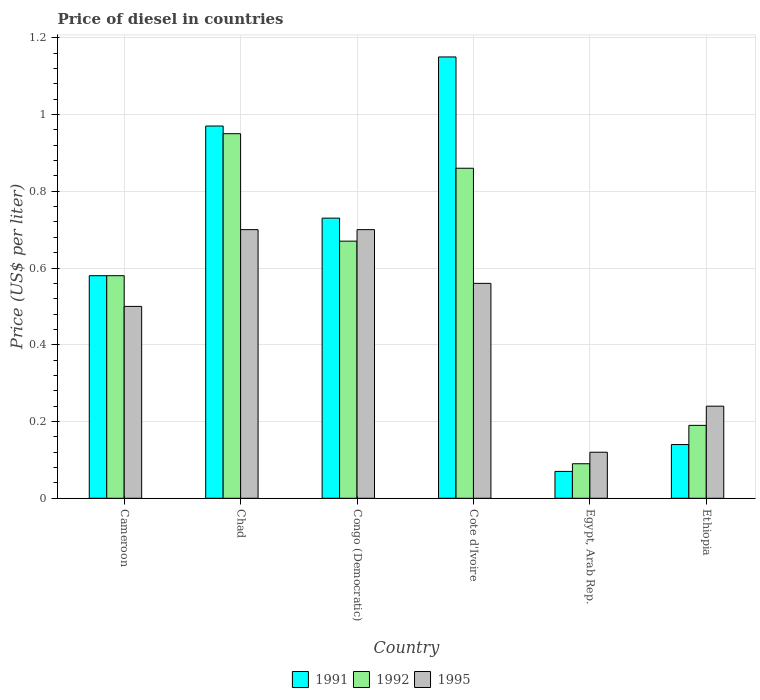How many different coloured bars are there?
Your response must be concise. 3. How many bars are there on the 3rd tick from the right?
Make the answer very short. 3. What is the label of the 3rd group of bars from the left?
Your answer should be compact. Congo (Democratic). In how many cases, is the number of bars for a given country not equal to the number of legend labels?
Make the answer very short. 0. What is the price of diesel in 1992 in Congo (Democratic)?
Ensure brevity in your answer.  0.67. Across all countries, what is the maximum price of diesel in 1992?
Make the answer very short. 0.95. Across all countries, what is the minimum price of diesel in 1992?
Ensure brevity in your answer.  0.09. In which country was the price of diesel in 1992 maximum?
Keep it short and to the point. Chad. In which country was the price of diesel in 1991 minimum?
Give a very brief answer. Egypt, Arab Rep. What is the total price of diesel in 1995 in the graph?
Provide a succinct answer. 2.82. What is the difference between the price of diesel in 1995 in Congo (Democratic) and that in Ethiopia?
Keep it short and to the point. 0.46. What is the difference between the price of diesel in 1992 in Ethiopia and the price of diesel in 1991 in Chad?
Provide a short and direct response. -0.78. What is the average price of diesel in 1991 per country?
Your answer should be very brief. 0.61. What is the difference between the price of diesel of/in 1991 and price of diesel of/in 1992 in Congo (Democratic)?
Your response must be concise. 0.06. What is the ratio of the price of diesel in 1995 in Chad to that in Egypt, Arab Rep.?
Give a very brief answer. 5.83. Is the price of diesel in 1992 in Congo (Democratic) less than that in Ethiopia?
Offer a terse response. No. What is the difference between the highest and the second highest price of diesel in 1995?
Your answer should be very brief. 0.14. What is the difference between the highest and the lowest price of diesel in 1992?
Your answer should be very brief. 0.86. In how many countries, is the price of diesel in 1992 greater than the average price of diesel in 1992 taken over all countries?
Your answer should be compact. 4. What does the 3rd bar from the right in Cameroon represents?
Ensure brevity in your answer.  1991. Is it the case that in every country, the sum of the price of diesel in 1992 and price of diesel in 1991 is greater than the price of diesel in 1995?
Ensure brevity in your answer.  Yes. How many countries are there in the graph?
Offer a very short reply. 6. What is the difference between two consecutive major ticks on the Y-axis?
Offer a terse response. 0.2. Does the graph contain any zero values?
Offer a very short reply. No. Where does the legend appear in the graph?
Your response must be concise. Bottom center. How many legend labels are there?
Offer a very short reply. 3. How are the legend labels stacked?
Keep it short and to the point. Horizontal. What is the title of the graph?
Make the answer very short. Price of diesel in countries. Does "1975" appear as one of the legend labels in the graph?
Offer a very short reply. No. What is the label or title of the Y-axis?
Your response must be concise. Price (US$ per liter). What is the Price (US$ per liter) of 1991 in Cameroon?
Provide a short and direct response. 0.58. What is the Price (US$ per liter) in 1992 in Cameroon?
Ensure brevity in your answer.  0.58. What is the Price (US$ per liter) of 1991 in Chad?
Offer a terse response. 0.97. What is the Price (US$ per liter) in 1995 in Chad?
Offer a very short reply. 0.7. What is the Price (US$ per liter) in 1991 in Congo (Democratic)?
Ensure brevity in your answer.  0.73. What is the Price (US$ per liter) in 1992 in Congo (Democratic)?
Ensure brevity in your answer.  0.67. What is the Price (US$ per liter) of 1991 in Cote d'Ivoire?
Make the answer very short. 1.15. What is the Price (US$ per liter) of 1992 in Cote d'Ivoire?
Your answer should be compact. 0.86. What is the Price (US$ per liter) of 1995 in Cote d'Ivoire?
Your response must be concise. 0.56. What is the Price (US$ per liter) of 1991 in Egypt, Arab Rep.?
Your answer should be compact. 0.07. What is the Price (US$ per liter) in 1992 in Egypt, Arab Rep.?
Offer a very short reply. 0.09. What is the Price (US$ per liter) of 1995 in Egypt, Arab Rep.?
Offer a terse response. 0.12. What is the Price (US$ per liter) of 1991 in Ethiopia?
Give a very brief answer. 0.14. What is the Price (US$ per liter) in 1992 in Ethiopia?
Make the answer very short. 0.19. What is the Price (US$ per liter) of 1995 in Ethiopia?
Your response must be concise. 0.24. Across all countries, what is the maximum Price (US$ per liter) of 1991?
Your answer should be compact. 1.15. Across all countries, what is the maximum Price (US$ per liter) of 1992?
Your response must be concise. 0.95. Across all countries, what is the maximum Price (US$ per liter) of 1995?
Keep it short and to the point. 0.7. Across all countries, what is the minimum Price (US$ per liter) in 1991?
Provide a short and direct response. 0.07. Across all countries, what is the minimum Price (US$ per liter) of 1992?
Ensure brevity in your answer.  0.09. Across all countries, what is the minimum Price (US$ per liter) of 1995?
Your response must be concise. 0.12. What is the total Price (US$ per liter) in 1991 in the graph?
Keep it short and to the point. 3.64. What is the total Price (US$ per liter) of 1992 in the graph?
Provide a short and direct response. 3.34. What is the total Price (US$ per liter) of 1995 in the graph?
Your answer should be very brief. 2.82. What is the difference between the Price (US$ per liter) in 1991 in Cameroon and that in Chad?
Ensure brevity in your answer.  -0.39. What is the difference between the Price (US$ per liter) in 1992 in Cameroon and that in Chad?
Your answer should be very brief. -0.37. What is the difference between the Price (US$ per liter) in 1995 in Cameroon and that in Chad?
Offer a terse response. -0.2. What is the difference between the Price (US$ per liter) in 1992 in Cameroon and that in Congo (Democratic)?
Give a very brief answer. -0.09. What is the difference between the Price (US$ per liter) in 1991 in Cameroon and that in Cote d'Ivoire?
Provide a succinct answer. -0.57. What is the difference between the Price (US$ per liter) in 1992 in Cameroon and that in Cote d'Ivoire?
Provide a short and direct response. -0.28. What is the difference between the Price (US$ per liter) in 1995 in Cameroon and that in Cote d'Ivoire?
Make the answer very short. -0.06. What is the difference between the Price (US$ per liter) in 1991 in Cameroon and that in Egypt, Arab Rep.?
Your answer should be compact. 0.51. What is the difference between the Price (US$ per liter) in 1992 in Cameroon and that in Egypt, Arab Rep.?
Give a very brief answer. 0.49. What is the difference between the Price (US$ per liter) in 1995 in Cameroon and that in Egypt, Arab Rep.?
Your response must be concise. 0.38. What is the difference between the Price (US$ per liter) in 1991 in Cameroon and that in Ethiopia?
Keep it short and to the point. 0.44. What is the difference between the Price (US$ per liter) in 1992 in Cameroon and that in Ethiopia?
Your answer should be compact. 0.39. What is the difference between the Price (US$ per liter) of 1995 in Cameroon and that in Ethiopia?
Make the answer very short. 0.26. What is the difference between the Price (US$ per liter) in 1991 in Chad and that in Congo (Democratic)?
Give a very brief answer. 0.24. What is the difference between the Price (US$ per liter) in 1992 in Chad and that in Congo (Democratic)?
Provide a short and direct response. 0.28. What is the difference between the Price (US$ per liter) of 1995 in Chad and that in Congo (Democratic)?
Make the answer very short. 0. What is the difference between the Price (US$ per liter) in 1991 in Chad and that in Cote d'Ivoire?
Provide a succinct answer. -0.18. What is the difference between the Price (US$ per liter) of 1992 in Chad and that in Cote d'Ivoire?
Your response must be concise. 0.09. What is the difference between the Price (US$ per liter) of 1995 in Chad and that in Cote d'Ivoire?
Keep it short and to the point. 0.14. What is the difference between the Price (US$ per liter) in 1992 in Chad and that in Egypt, Arab Rep.?
Offer a very short reply. 0.86. What is the difference between the Price (US$ per liter) in 1995 in Chad and that in Egypt, Arab Rep.?
Your response must be concise. 0.58. What is the difference between the Price (US$ per liter) of 1991 in Chad and that in Ethiopia?
Your answer should be very brief. 0.83. What is the difference between the Price (US$ per liter) in 1992 in Chad and that in Ethiopia?
Make the answer very short. 0.76. What is the difference between the Price (US$ per liter) in 1995 in Chad and that in Ethiopia?
Give a very brief answer. 0.46. What is the difference between the Price (US$ per liter) of 1991 in Congo (Democratic) and that in Cote d'Ivoire?
Ensure brevity in your answer.  -0.42. What is the difference between the Price (US$ per liter) in 1992 in Congo (Democratic) and that in Cote d'Ivoire?
Your answer should be very brief. -0.19. What is the difference between the Price (US$ per liter) of 1995 in Congo (Democratic) and that in Cote d'Ivoire?
Provide a short and direct response. 0.14. What is the difference between the Price (US$ per liter) of 1991 in Congo (Democratic) and that in Egypt, Arab Rep.?
Provide a short and direct response. 0.66. What is the difference between the Price (US$ per liter) of 1992 in Congo (Democratic) and that in Egypt, Arab Rep.?
Your response must be concise. 0.58. What is the difference between the Price (US$ per liter) of 1995 in Congo (Democratic) and that in Egypt, Arab Rep.?
Give a very brief answer. 0.58. What is the difference between the Price (US$ per liter) in 1991 in Congo (Democratic) and that in Ethiopia?
Ensure brevity in your answer.  0.59. What is the difference between the Price (US$ per liter) in 1992 in Congo (Democratic) and that in Ethiopia?
Ensure brevity in your answer.  0.48. What is the difference between the Price (US$ per liter) of 1995 in Congo (Democratic) and that in Ethiopia?
Provide a short and direct response. 0.46. What is the difference between the Price (US$ per liter) in 1991 in Cote d'Ivoire and that in Egypt, Arab Rep.?
Provide a short and direct response. 1.08. What is the difference between the Price (US$ per liter) in 1992 in Cote d'Ivoire and that in Egypt, Arab Rep.?
Offer a terse response. 0.77. What is the difference between the Price (US$ per liter) of 1995 in Cote d'Ivoire and that in Egypt, Arab Rep.?
Offer a terse response. 0.44. What is the difference between the Price (US$ per liter) in 1991 in Cote d'Ivoire and that in Ethiopia?
Provide a succinct answer. 1.01. What is the difference between the Price (US$ per liter) of 1992 in Cote d'Ivoire and that in Ethiopia?
Make the answer very short. 0.67. What is the difference between the Price (US$ per liter) of 1995 in Cote d'Ivoire and that in Ethiopia?
Provide a succinct answer. 0.32. What is the difference between the Price (US$ per liter) of 1991 in Egypt, Arab Rep. and that in Ethiopia?
Offer a very short reply. -0.07. What is the difference between the Price (US$ per liter) of 1995 in Egypt, Arab Rep. and that in Ethiopia?
Make the answer very short. -0.12. What is the difference between the Price (US$ per liter) in 1991 in Cameroon and the Price (US$ per liter) in 1992 in Chad?
Keep it short and to the point. -0.37. What is the difference between the Price (US$ per liter) in 1991 in Cameroon and the Price (US$ per liter) in 1995 in Chad?
Give a very brief answer. -0.12. What is the difference between the Price (US$ per liter) in 1992 in Cameroon and the Price (US$ per liter) in 1995 in Chad?
Keep it short and to the point. -0.12. What is the difference between the Price (US$ per liter) in 1991 in Cameroon and the Price (US$ per liter) in 1992 in Congo (Democratic)?
Provide a succinct answer. -0.09. What is the difference between the Price (US$ per liter) in 1991 in Cameroon and the Price (US$ per liter) in 1995 in Congo (Democratic)?
Provide a succinct answer. -0.12. What is the difference between the Price (US$ per liter) in 1992 in Cameroon and the Price (US$ per liter) in 1995 in Congo (Democratic)?
Your answer should be compact. -0.12. What is the difference between the Price (US$ per liter) of 1991 in Cameroon and the Price (US$ per liter) of 1992 in Cote d'Ivoire?
Keep it short and to the point. -0.28. What is the difference between the Price (US$ per liter) of 1991 in Cameroon and the Price (US$ per liter) of 1995 in Cote d'Ivoire?
Keep it short and to the point. 0.02. What is the difference between the Price (US$ per liter) in 1992 in Cameroon and the Price (US$ per liter) in 1995 in Cote d'Ivoire?
Offer a very short reply. 0.02. What is the difference between the Price (US$ per liter) of 1991 in Cameroon and the Price (US$ per liter) of 1992 in Egypt, Arab Rep.?
Provide a succinct answer. 0.49. What is the difference between the Price (US$ per liter) in 1991 in Cameroon and the Price (US$ per liter) in 1995 in Egypt, Arab Rep.?
Keep it short and to the point. 0.46. What is the difference between the Price (US$ per liter) in 1992 in Cameroon and the Price (US$ per liter) in 1995 in Egypt, Arab Rep.?
Ensure brevity in your answer.  0.46. What is the difference between the Price (US$ per liter) in 1991 in Cameroon and the Price (US$ per liter) in 1992 in Ethiopia?
Offer a terse response. 0.39. What is the difference between the Price (US$ per liter) in 1991 in Cameroon and the Price (US$ per liter) in 1995 in Ethiopia?
Give a very brief answer. 0.34. What is the difference between the Price (US$ per liter) of 1992 in Cameroon and the Price (US$ per liter) of 1995 in Ethiopia?
Your response must be concise. 0.34. What is the difference between the Price (US$ per liter) in 1991 in Chad and the Price (US$ per liter) in 1992 in Congo (Democratic)?
Offer a very short reply. 0.3. What is the difference between the Price (US$ per liter) of 1991 in Chad and the Price (US$ per liter) of 1995 in Congo (Democratic)?
Provide a succinct answer. 0.27. What is the difference between the Price (US$ per liter) of 1992 in Chad and the Price (US$ per liter) of 1995 in Congo (Democratic)?
Provide a short and direct response. 0.25. What is the difference between the Price (US$ per liter) of 1991 in Chad and the Price (US$ per liter) of 1992 in Cote d'Ivoire?
Your response must be concise. 0.11. What is the difference between the Price (US$ per liter) in 1991 in Chad and the Price (US$ per liter) in 1995 in Cote d'Ivoire?
Ensure brevity in your answer.  0.41. What is the difference between the Price (US$ per liter) of 1992 in Chad and the Price (US$ per liter) of 1995 in Cote d'Ivoire?
Offer a terse response. 0.39. What is the difference between the Price (US$ per liter) in 1991 in Chad and the Price (US$ per liter) in 1995 in Egypt, Arab Rep.?
Keep it short and to the point. 0.85. What is the difference between the Price (US$ per liter) of 1992 in Chad and the Price (US$ per liter) of 1995 in Egypt, Arab Rep.?
Your response must be concise. 0.83. What is the difference between the Price (US$ per liter) of 1991 in Chad and the Price (US$ per liter) of 1992 in Ethiopia?
Offer a very short reply. 0.78. What is the difference between the Price (US$ per liter) in 1991 in Chad and the Price (US$ per liter) in 1995 in Ethiopia?
Offer a terse response. 0.73. What is the difference between the Price (US$ per liter) in 1992 in Chad and the Price (US$ per liter) in 1995 in Ethiopia?
Keep it short and to the point. 0.71. What is the difference between the Price (US$ per liter) in 1991 in Congo (Democratic) and the Price (US$ per liter) in 1992 in Cote d'Ivoire?
Keep it short and to the point. -0.13. What is the difference between the Price (US$ per liter) of 1991 in Congo (Democratic) and the Price (US$ per liter) of 1995 in Cote d'Ivoire?
Give a very brief answer. 0.17. What is the difference between the Price (US$ per liter) of 1992 in Congo (Democratic) and the Price (US$ per liter) of 1995 in Cote d'Ivoire?
Give a very brief answer. 0.11. What is the difference between the Price (US$ per liter) of 1991 in Congo (Democratic) and the Price (US$ per liter) of 1992 in Egypt, Arab Rep.?
Your answer should be compact. 0.64. What is the difference between the Price (US$ per liter) in 1991 in Congo (Democratic) and the Price (US$ per liter) in 1995 in Egypt, Arab Rep.?
Make the answer very short. 0.61. What is the difference between the Price (US$ per liter) in 1992 in Congo (Democratic) and the Price (US$ per liter) in 1995 in Egypt, Arab Rep.?
Make the answer very short. 0.55. What is the difference between the Price (US$ per liter) in 1991 in Congo (Democratic) and the Price (US$ per liter) in 1992 in Ethiopia?
Provide a short and direct response. 0.54. What is the difference between the Price (US$ per liter) of 1991 in Congo (Democratic) and the Price (US$ per liter) of 1995 in Ethiopia?
Keep it short and to the point. 0.49. What is the difference between the Price (US$ per liter) in 1992 in Congo (Democratic) and the Price (US$ per liter) in 1995 in Ethiopia?
Offer a terse response. 0.43. What is the difference between the Price (US$ per liter) in 1991 in Cote d'Ivoire and the Price (US$ per liter) in 1992 in Egypt, Arab Rep.?
Your response must be concise. 1.06. What is the difference between the Price (US$ per liter) in 1992 in Cote d'Ivoire and the Price (US$ per liter) in 1995 in Egypt, Arab Rep.?
Your answer should be compact. 0.74. What is the difference between the Price (US$ per liter) of 1991 in Cote d'Ivoire and the Price (US$ per liter) of 1992 in Ethiopia?
Provide a short and direct response. 0.96. What is the difference between the Price (US$ per liter) in 1991 in Cote d'Ivoire and the Price (US$ per liter) in 1995 in Ethiopia?
Your answer should be very brief. 0.91. What is the difference between the Price (US$ per liter) in 1992 in Cote d'Ivoire and the Price (US$ per liter) in 1995 in Ethiopia?
Offer a very short reply. 0.62. What is the difference between the Price (US$ per liter) in 1991 in Egypt, Arab Rep. and the Price (US$ per liter) in 1992 in Ethiopia?
Provide a short and direct response. -0.12. What is the difference between the Price (US$ per liter) of 1991 in Egypt, Arab Rep. and the Price (US$ per liter) of 1995 in Ethiopia?
Provide a short and direct response. -0.17. What is the average Price (US$ per liter) in 1991 per country?
Make the answer very short. 0.61. What is the average Price (US$ per liter) in 1992 per country?
Keep it short and to the point. 0.56. What is the average Price (US$ per liter) of 1995 per country?
Your answer should be very brief. 0.47. What is the difference between the Price (US$ per liter) in 1991 and Price (US$ per liter) in 1992 in Cameroon?
Provide a succinct answer. 0. What is the difference between the Price (US$ per liter) of 1992 and Price (US$ per liter) of 1995 in Cameroon?
Keep it short and to the point. 0.08. What is the difference between the Price (US$ per liter) of 1991 and Price (US$ per liter) of 1995 in Chad?
Your answer should be very brief. 0.27. What is the difference between the Price (US$ per liter) in 1992 and Price (US$ per liter) in 1995 in Chad?
Provide a short and direct response. 0.25. What is the difference between the Price (US$ per liter) of 1991 and Price (US$ per liter) of 1992 in Congo (Democratic)?
Provide a succinct answer. 0.06. What is the difference between the Price (US$ per liter) in 1992 and Price (US$ per liter) in 1995 in Congo (Democratic)?
Ensure brevity in your answer.  -0.03. What is the difference between the Price (US$ per liter) in 1991 and Price (US$ per liter) in 1992 in Cote d'Ivoire?
Give a very brief answer. 0.29. What is the difference between the Price (US$ per liter) in 1991 and Price (US$ per liter) in 1995 in Cote d'Ivoire?
Your answer should be very brief. 0.59. What is the difference between the Price (US$ per liter) of 1991 and Price (US$ per liter) of 1992 in Egypt, Arab Rep.?
Give a very brief answer. -0.02. What is the difference between the Price (US$ per liter) of 1991 and Price (US$ per liter) of 1995 in Egypt, Arab Rep.?
Make the answer very short. -0.05. What is the difference between the Price (US$ per liter) in 1992 and Price (US$ per liter) in 1995 in Egypt, Arab Rep.?
Your answer should be very brief. -0.03. What is the difference between the Price (US$ per liter) in 1992 and Price (US$ per liter) in 1995 in Ethiopia?
Make the answer very short. -0.05. What is the ratio of the Price (US$ per liter) of 1991 in Cameroon to that in Chad?
Provide a short and direct response. 0.6. What is the ratio of the Price (US$ per liter) of 1992 in Cameroon to that in Chad?
Your response must be concise. 0.61. What is the ratio of the Price (US$ per liter) in 1995 in Cameroon to that in Chad?
Make the answer very short. 0.71. What is the ratio of the Price (US$ per liter) of 1991 in Cameroon to that in Congo (Democratic)?
Your answer should be compact. 0.79. What is the ratio of the Price (US$ per liter) of 1992 in Cameroon to that in Congo (Democratic)?
Make the answer very short. 0.87. What is the ratio of the Price (US$ per liter) of 1991 in Cameroon to that in Cote d'Ivoire?
Offer a terse response. 0.5. What is the ratio of the Price (US$ per liter) in 1992 in Cameroon to that in Cote d'Ivoire?
Your answer should be compact. 0.67. What is the ratio of the Price (US$ per liter) of 1995 in Cameroon to that in Cote d'Ivoire?
Make the answer very short. 0.89. What is the ratio of the Price (US$ per liter) of 1991 in Cameroon to that in Egypt, Arab Rep.?
Provide a short and direct response. 8.29. What is the ratio of the Price (US$ per liter) in 1992 in Cameroon to that in Egypt, Arab Rep.?
Offer a terse response. 6.44. What is the ratio of the Price (US$ per liter) in 1995 in Cameroon to that in Egypt, Arab Rep.?
Offer a terse response. 4.17. What is the ratio of the Price (US$ per liter) in 1991 in Cameroon to that in Ethiopia?
Make the answer very short. 4.14. What is the ratio of the Price (US$ per liter) in 1992 in Cameroon to that in Ethiopia?
Your answer should be compact. 3.05. What is the ratio of the Price (US$ per liter) of 1995 in Cameroon to that in Ethiopia?
Offer a terse response. 2.08. What is the ratio of the Price (US$ per liter) in 1991 in Chad to that in Congo (Democratic)?
Give a very brief answer. 1.33. What is the ratio of the Price (US$ per liter) of 1992 in Chad to that in Congo (Democratic)?
Ensure brevity in your answer.  1.42. What is the ratio of the Price (US$ per liter) in 1991 in Chad to that in Cote d'Ivoire?
Ensure brevity in your answer.  0.84. What is the ratio of the Price (US$ per liter) of 1992 in Chad to that in Cote d'Ivoire?
Provide a succinct answer. 1.1. What is the ratio of the Price (US$ per liter) in 1995 in Chad to that in Cote d'Ivoire?
Keep it short and to the point. 1.25. What is the ratio of the Price (US$ per liter) of 1991 in Chad to that in Egypt, Arab Rep.?
Ensure brevity in your answer.  13.86. What is the ratio of the Price (US$ per liter) of 1992 in Chad to that in Egypt, Arab Rep.?
Your answer should be very brief. 10.56. What is the ratio of the Price (US$ per liter) in 1995 in Chad to that in Egypt, Arab Rep.?
Your answer should be compact. 5.83. What is the ratio of the Price (US$ per liter) of 1991 in Chad to that in Ethiopia?
Provide a succinct answer. 6.93. What is the ratio of the Price (US$ per liter) of 1992 in Chad to that in Ethiopia?
Offer a very short reply. 5. What is the ratio of the Price (US$ per liter) in 1995 in Chad to that in Ethiopia?
Keep it short and to the point. 2.92. What is the ratio of the Price (US$ per liter) of 1991 in Congo (Democratic) to that in Cote d'Ivoire?
Provide a short and direct response. 0.63. What is the ratio of the Price (US$ per liter) in 1992 in Congo (Democratic) to that in Cote d'Ivoire?
Your answer should be compact. 0.78. What is the ratio of the Price (US$ per liter) in 1995 in Congo (Democratic) to that in Cote d'Ivoire?
Your response must be concise. 1.25. What is the ratio of the Price (US$ per liter) in 1991 in Congo (Democratic) to that in Egypt, Arab Rep.?
Give a very brief answer. 10.43. What is the ratio of the Price (US$ per liter) of 1992 in Congo (Democratic) to that in Egypt, Arab Rep.?
Provide a succinct answer. 7.44. What is the ratio of the Price (US$ per liter) of 1995 in Congo (Democratic) to that in Egypt, Arab Rep.?
Offer a very short reply. 5.83. What is the ratio of the Price (US$ per liter) in 1991 in Congo (Democratic) to that in Ethiopia?
Give a very brief answer. 5.21. What is the ratio of the Price (US$ per liter) of 1992 in Congo (Democratic) to that in Ethiopia?
Provide a short and direct response. 3.53. What is the ratio of the Price (US$ per liter) in 1995 in Congo (Democratic) to that in Ethiopia?
Provide a short and direct response. 2.92. What is the ratio of the Price (US$ per liter) of 1991 in Cote d'Ivoire to that in Egypt, Arab Rep.?
Provide a succinct answer. 16.43. What is the ratio of the Price (US$ per liter) in 1992 in Cote d'Ivoire to that in Egypt, Arab Rep.?
Keep it short and to the point. 9.56. What is the ratio of the Price (US$ per liter) of 1995 in Cote d'Ivoire to that in Egypt, Arab Rep.?
Your answer should be very brief. 4.67. What is the ratio of the Price (US$ per liter) of 1991 in Cote d'Ivoire to that in Ethiopia?
Make the answer very short. 8.21. What is the ratio of the Price (US$ per liter) of 1992 in Cote d'Ivoire to that in Ethiopia?
Your answer should be compact. 4.53. What is the ratio of the Price (US$ per liter) in 1995 in Cote d'Ivoire to that in Ethiopia?
Offer a terse response. 2.33. What is the ratio of the Price (US$ per liter) in 1991 in Egypt, Arab Rep. to that in Ethiopia?
Your answer should be very brief. 0.5. What is the ratio of the Price (US$ per liter) in 1992 in Egypt, Arab Rep. to that in Ethiopia?
Make the answer very short. 0.47. What is the ratio of the Price (US$ per liter) of 1995 in Egypt, Arab Rep. to that in Ethiopia?
Your answer should be very brief. 0.5. What is the difference between the highest and the second highest Price (US$ per liter) of 1991?
Provide a short and direct response. 0.18. What is the difference between the highest and the second highest Price (US$ per liter) of 1992?
Ensure brevity in your answer.  0.09. What is the difference between the highest and the second highest Price (US$ per liter) of 1995?
Make the answer very short. 0. What is the difference between the highest and the lowest Price (US$ per liter) of 1991?
Give a very brief answer. 1.08. What is the difference between the highest and the lowest Price (US$ per liter) in 1992?
Provide a short and direct response. 0.86. What is the difference between the highest and the lowest Price (US$ per liter) of 1995?
Your answer should be very brief. 0.58. 